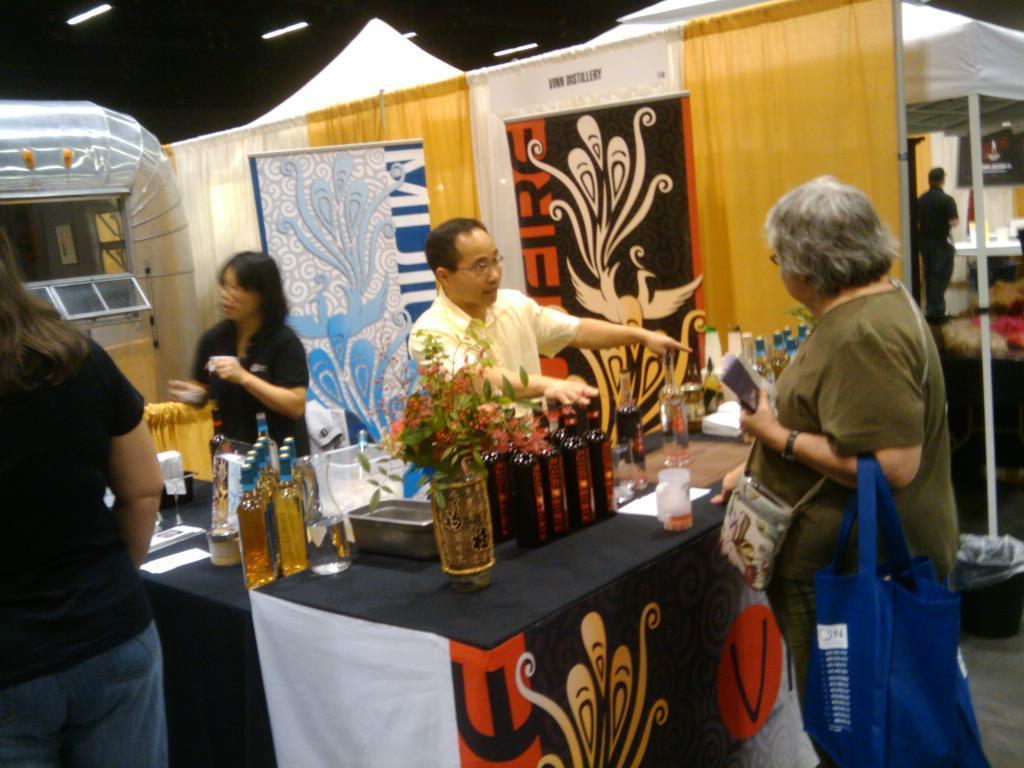Can you describe this image briefly? This picture is of inside. On the right there is a woman wearing bag, holding some papers and standing. In the center there is a table on the top of which a flower vase, bottles are placed, behind that there is a man standing. On the left there is a woman wearing black color t-shirt and standing and in the left corner there is a woman wearing black color t-shirt and standing. In the background we can see the tent and a man behind that rent and in the left corner we can see the machine. 